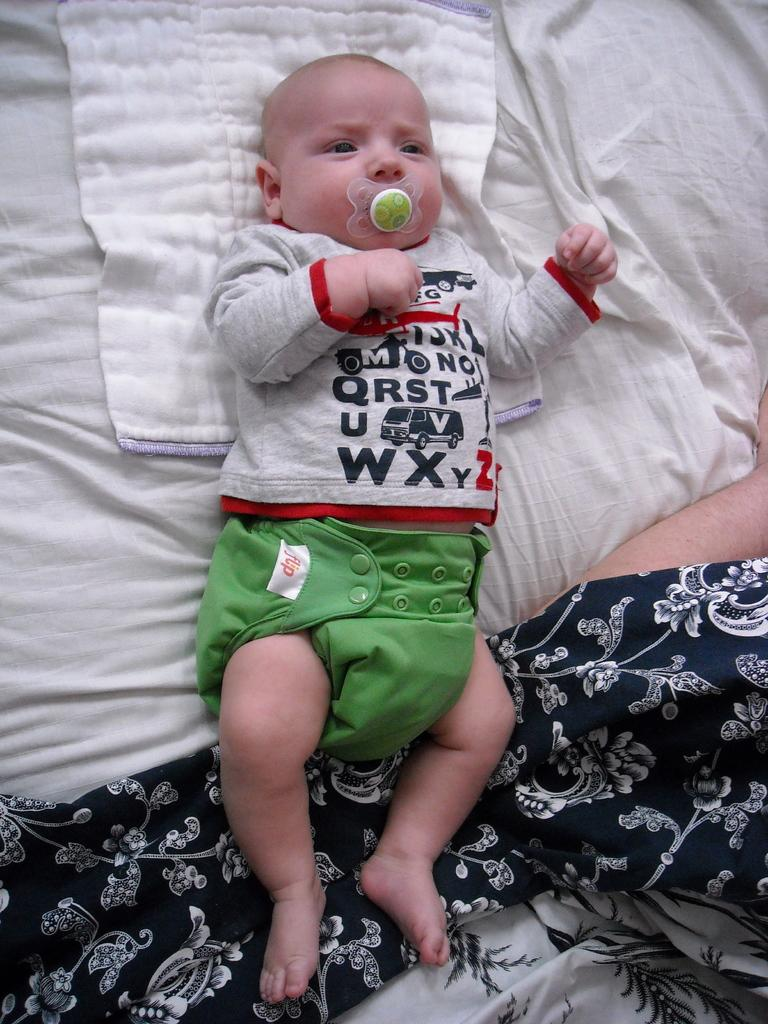What is the main subject of the image? There is a baby lying in the image. What object is associated with the baby in the image? There is a pacifier in the image. What else can be seen in the image besides the baby and pacifier? There are clothes in the image. Can you identify any part of a person in the image? A hand of a person is visible in the image. How many shoes can be seen in the image? There are no shoes visible in the image. What type of needle is being used by the baby in the image? There is no needle present in the image, and the baby is not performing any activity that would require a needle. 